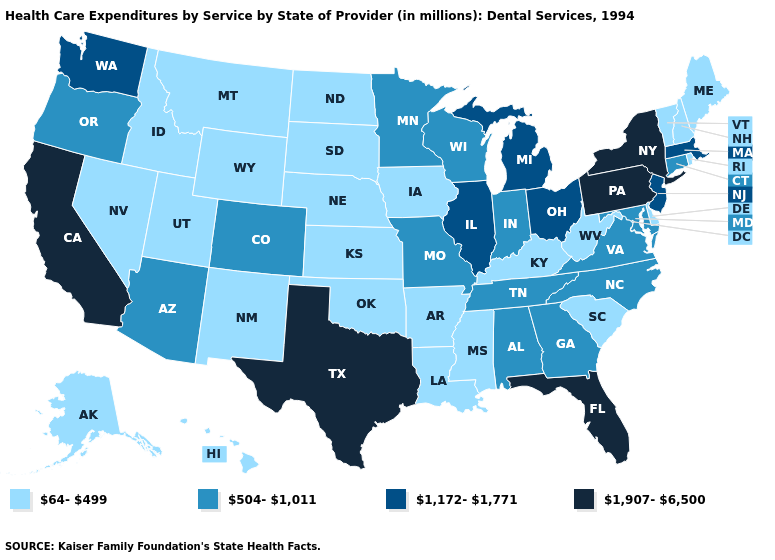Among the states that border Colorado , does Kansas have the lowest value?
Write a very short answer. Yes. What is the lowest value in states that border North Carolina?
Write a very short answer. 64-499. Name the states that have a value in the range 64-499?
Short answer required. Alaska, Arkansas, Delaware, Hawaii, Idaho, Iowa, Kansas, Kentucky, Louisiana, Maine, Mississippi, Montana, Nebraska, Nevada, New Hampshire, New Mexico, North Dakota, Oklahoma, Rhode Island, South Carolina, South Dakota, Utah, Vermont, West Virginia, Wyoming. Name the states that have a value in the range 504-1,011?
Concise answer only. Alabama, Arizona, Colorado, Connecticut, Georgia, Indiana, Maryland, Minnesota, Missouri, North Carolina, Oregon, Tennessee, Virginia, Wisconsin. What is the value of West Virginia?
Be succinct. 64-499. Among the states that border Florida , which have the highest value?
Give a very brief answer. Alabama, Georgia. Name the states that have a value in the range 1,172-1,771?
Write a very short answer. Illinois, Massachusetts, Michigan, New Jersey, Ohio, Washington. Name the states that have a value in the range 504-1,011?
Keep it brief. Alabama, Arizona, Colorado, Connecticut, Georgia, Indiana, Maryland, Minnesota, Missouri, North Carolina, Oregon, Tennessee, Virginia, Wisconsin. What is the value of Maryland?
Concise answer only. 504-1,011. Which states hav the highest value in the South?
Give a very brief answer. Florida, Texas. Which states hav the highest value in the West?
Be succinct. California. Which states have the highest value in the USA?
Give a very brief answer. California, Florida, New York, Pennsylvania, Texas. What is the lowest value in states that border Montana?
Keep it brief. 64-499. Which states have the highest value in the USA?
Be succinct. California, Florida, New York, Pennsylvania, Texas. What is the lowest value in the Northeast?
Write a very short answer. 64-499. 